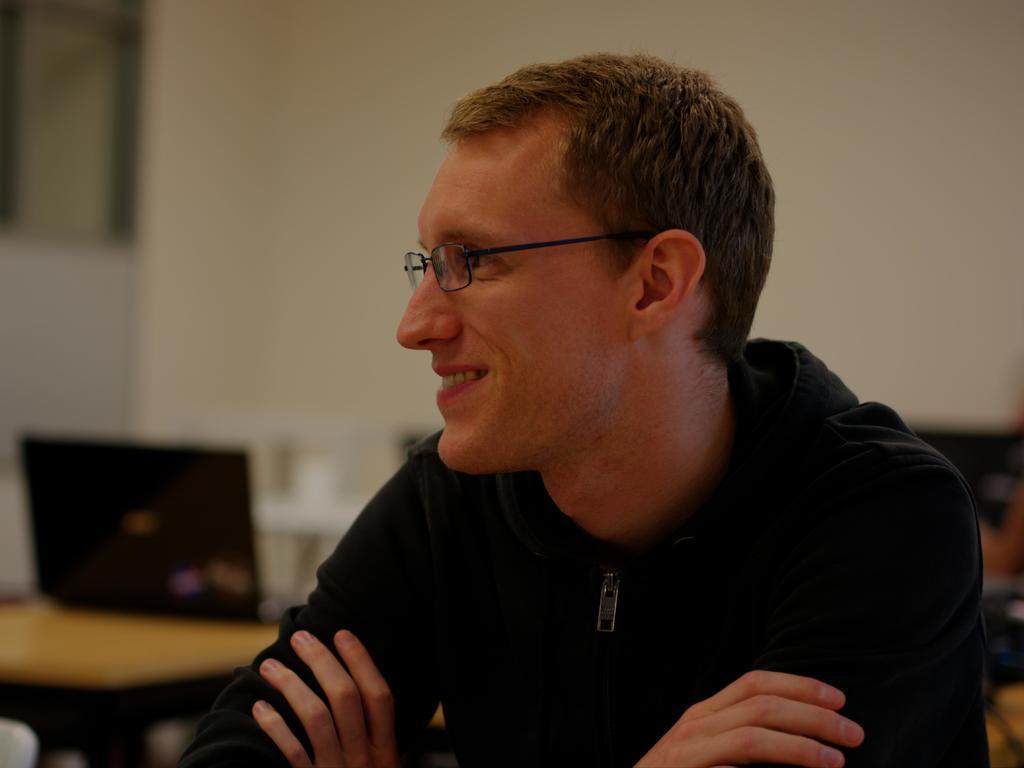In one or two sentences, can you explain what this image depicts? In this image we can a man is smiling. He is wearing black color hoodie. Behind on table laptop is there. 